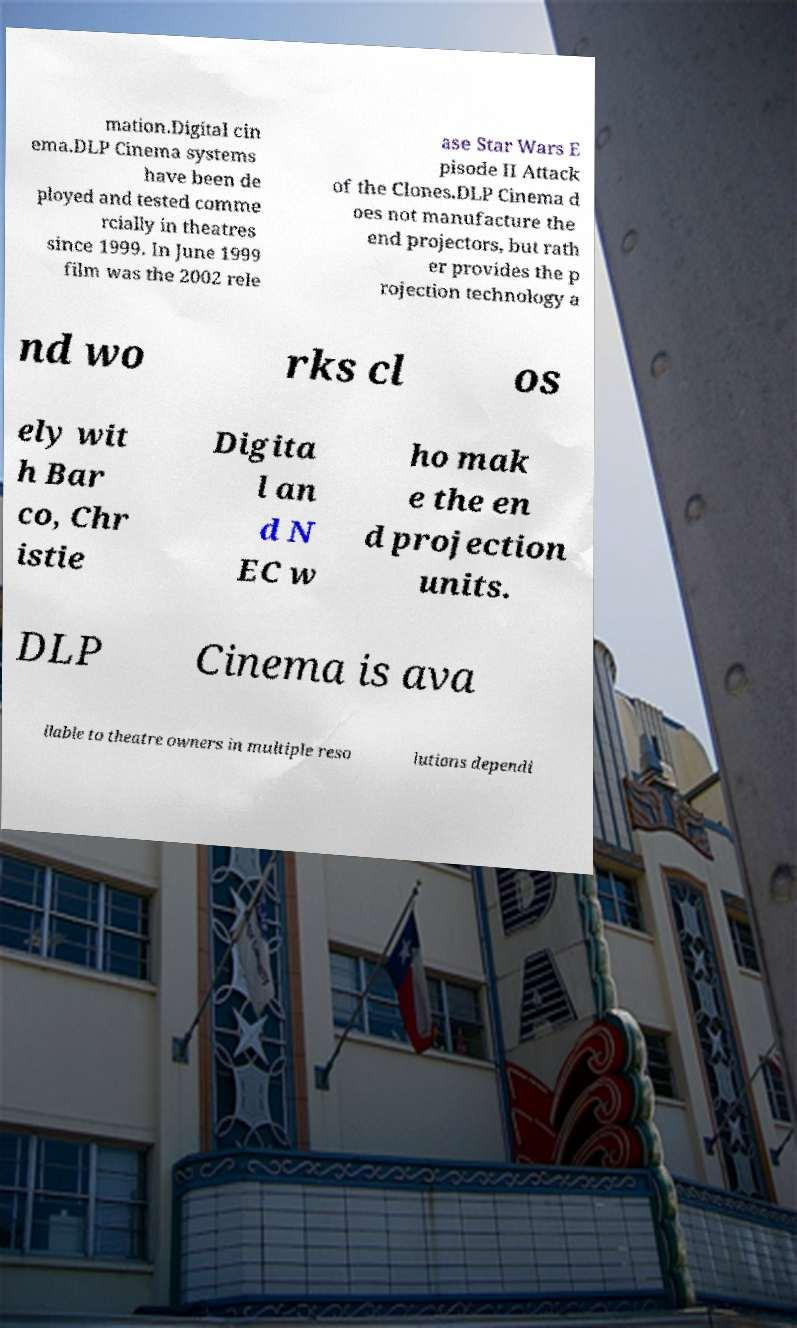What messages or text are displayed in this image? I need them in a readable, typed format. mation.Digital cin ema.DLP Cinema systems have been de ployed and tested comme rcially in theatres since 1999. In June 1999 film was the 2002 rele ase Star Wars E pisode II Attack of the Clones.DLP Cinema d oes not manufacture the end projectors, but rath er provides the p rojection technology a nd wo rks cl os ely wit h Bar co, Chr istie Digita l an d N EC w ho mak e the en d projection units. DLP Cinema is ava ilable to theatre owners in multiple reso lutions dependi 